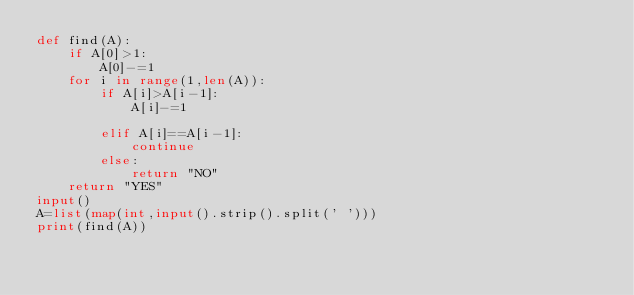Convert code to text. <code><loc_0><loc_0><loc_500><loc_500><_Python_>def find(A):
    if A[0]>1:
        A[0]-=1
    for i in range(1,len(A)):
        if A[i]>A[i-1]:
            A[i]-=1
        
        elif A[i]==A[i-1]:
            continue
        else:
            return "NO"
    return "YES"
input()
A=list(map(int,input().strip().split(' ')))
print(find(A))</code> 